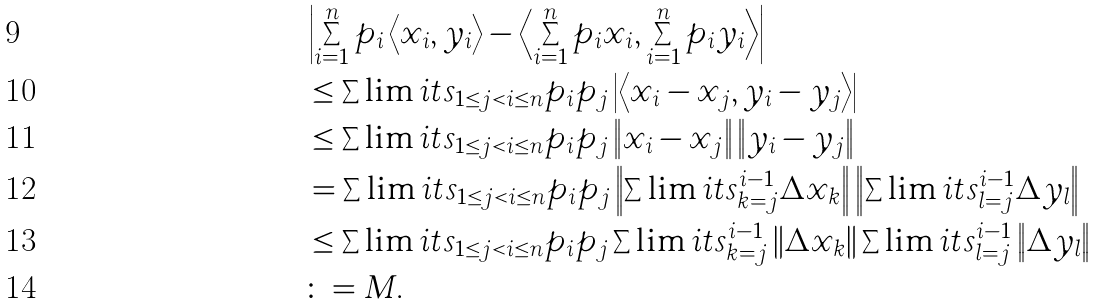Convert formula to latex. <formula><loc_0><loc_0><loc_500><loc_500>& \left | \sum _ { i = 1 } ^ { n } p _ { i } \left \langle x _ { i } , y _ { i } \right \rangle - \left \langle \sum _ { i = 1 } ^ { n } p _ { i } x _ { i } , \sum _ { i = 1 } ^ { n } p _ { i } y _ { i } \right \rangle \right | \\ & \leq \sum \lim i t s _ { 1 \leq j < i \leq n } p _ { i } p _ { j } \left | \left \langle x _ { i } - x _ { j } , y _ { i } - y _ { j } \right \rangle \right | \\ & \leq \sum \lim i t s _ { 1 \leq j < i \leq n } p _ { i } p _ { j } \left \| x _ { i } - x _ { j } \right \| \left \| y _ { i } - y _ { j } \right \| \\ & = \sum \lim i t s _ { 1 \leq j < i \leq n } p _ { i } p _ { j } \left \| \sum \lim i t s _ { k = j } ^ { i - 1 } \Delta x _ { k } \right \| \left \| \sum \lim i t s _ { l = j } ^ { i - 1 } \Delta y _ { l } \right \| \\ & \leq \sum \lim i t s _ { 1 \leq j < i \leq n } p _ { i } p _ { j } \sum \lim i t s _ { k = j } ^ { i - 1 } \left \| \Delta x _ { k } \right \| \sum \lim i t s _ { l = j } ^ { i - 1 } \left \| \Delta y _ { l } \right \| \\ & \colon = M .</formula> 